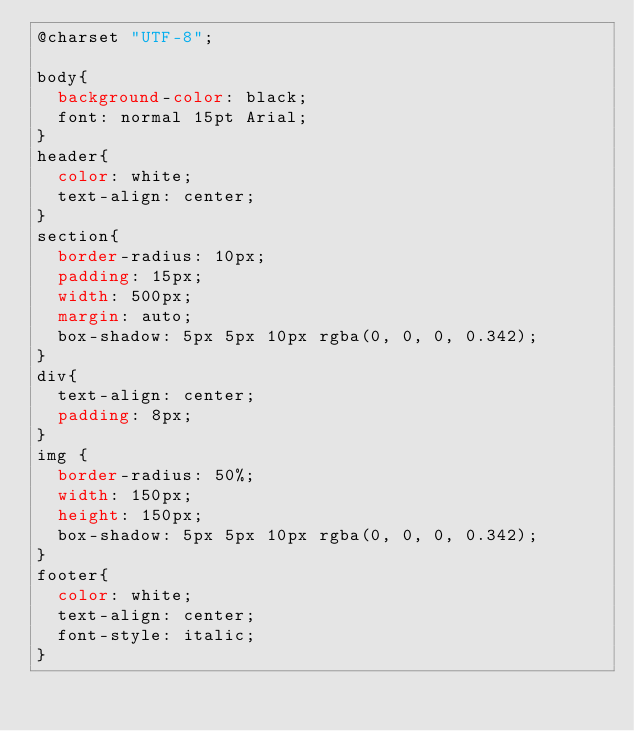Convert code to text. <code><loc_0><loc_0><loc_500><loc_500><_CSS_>@charset "UTF-8";

body{
  background-color: black;
  font: normal 15pt Arial;
}
header{
  color: white;
  text-align: center;
}
section{
  border-radius: 10px;
  padding: 15px;
  width: 500px;
  margin: auto;
  box-shadow: 5px 5px 10px rgba(0, 0, 0, 0.342);
}
div{
  text-align: center;
  padding: 8px;
}
img {
  border-radius: 50%;
  width: 150px;
  height: 150px;
  box-shadow: 5px 5px 10px rgba(0, 0, 0, 0.342);
}
footer{
  color: white;
  text-align: center;
  font-style: italic;
}</code> 